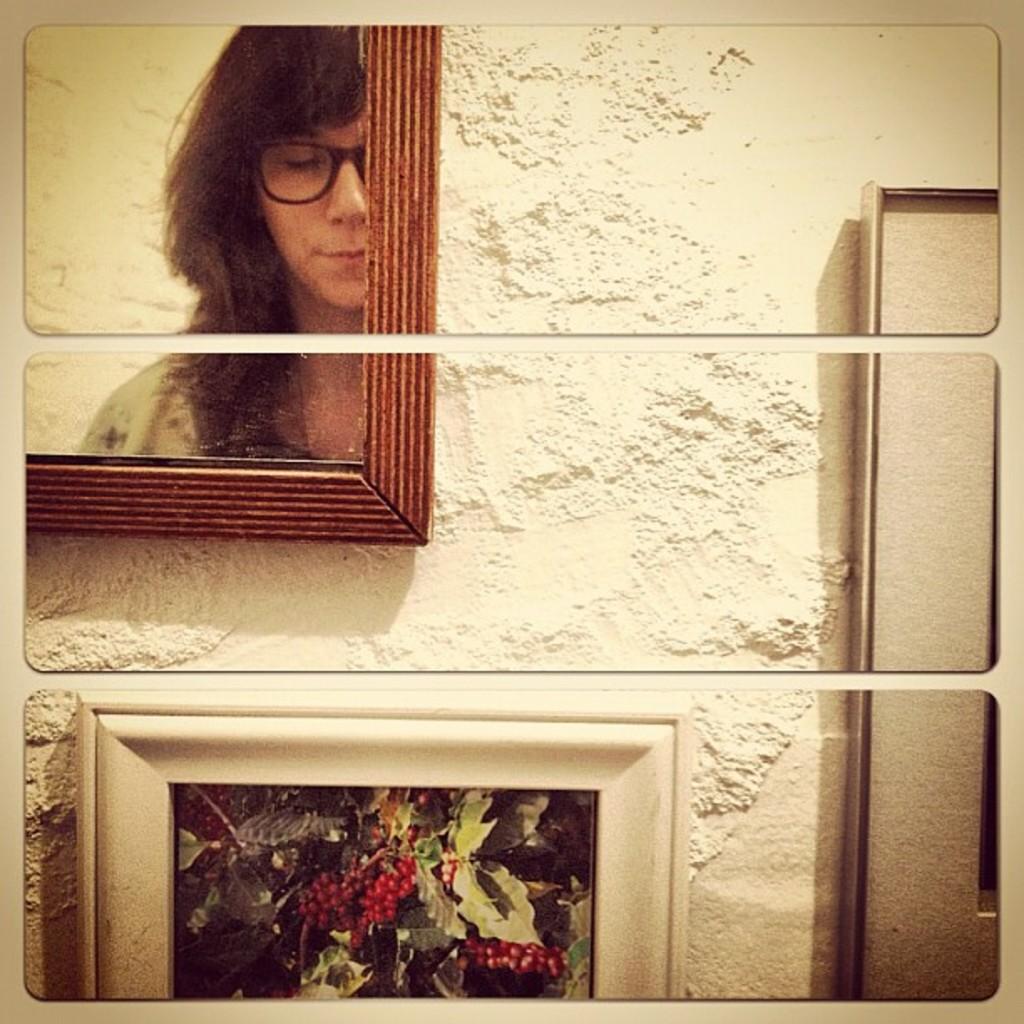How would you summarize this image in a sentence or two? In this image I can see the frame is split into three pieces. I can see the person's reflection in the mirror and few frames are attached to the cream color surface. 